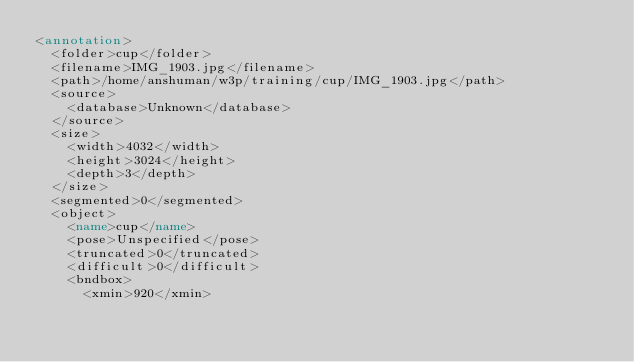<code> <loc_0><loc_0><loc_500><loc_500><_XML_><annotation>
	<folder>cup</folder>
	<filename>IMG_1903.jpg</filename>
	<path>/home/anshuman/w3p/training/cup/IMG_1903.jpg</path>
	<source>
		<database>Unknown</database>
	</source>
	<size>
		<width>4032</width>
		<height>3024</height>
		<depth>3</depth>
	</size>
	<segmented>0</segmented>
	<object>
		<name>cup</name>
		<pose>Unspecified</pose>
		<truncated>0</truncated>
		<difficult>0</difficult>
		<bndbox>
			<xmin>920</xmin></code> 